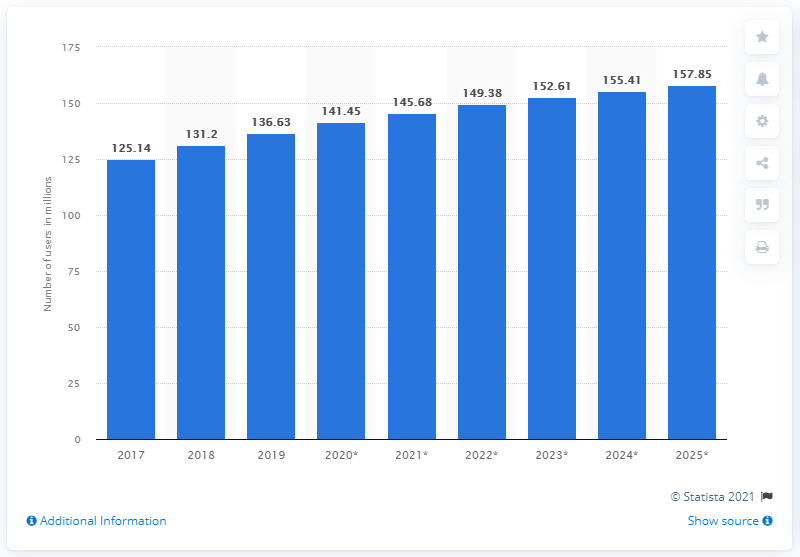Give some essential details in this illustration. In 2019, there were approximately 136.63 million Facebook users in Brazil. 